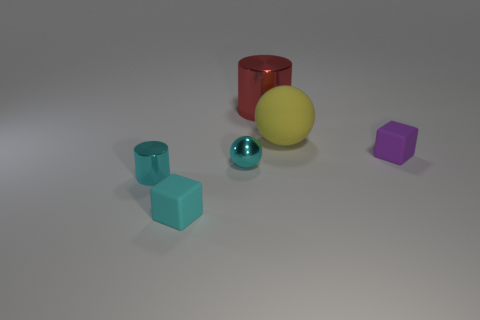What is the material of the small cyan sphere?
Keep it short and to the point. Metal. Do the small ball and the tiny shiny cylinder have the same color?
Make the answer very short. Yes. What number of other objects are there of the same material as the large red object?
Make the answer very short. 2. Is the number of big metallic things that are behind the red metallic object the same as the number of red things?
Offer a very short reply. No. Does the cylinder that is behind the rubber sphere have the same size as the large yellow rubber ball?
Offer a terse response. Yes. How many red metallic things are left of the cyan cube?
Offer a very short reply. 0. What material is the tiny thing that is behind the tiny metal cylinder and to the left of the tiny purple thing?
Make the answer very short. Metal. What number of large things are either cyan metal cubes or cyan blocks?
Keep it short and to the point. 0. How big is the red metallic object?
Provide a short and direct response. Large. What is the shape of the red shiny thing?
Provide a succinct answer. Cylinder. 